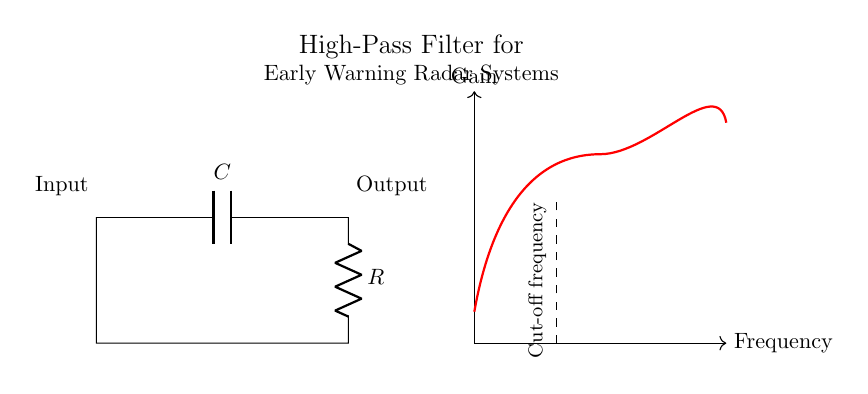What type of circuit is shown? The circuit is a high-pass filter, which is designed to allow high-frequency signals to pass through while attenuating low-frequency signals. This is indicated by the arrangement of components and the purpose stated in the title.
Answer: high-pass filter What are the components used in the circuit? The circuit contains a capacitor and a resistor, as indicated by the labels in the diagram. The capacitor is represented by C and the resistor by R.
Answer: capacitor and resistor What is the function of the capacitor in this circuit? The capacitor in a high-pass filter circuit blocks low-frequency signals while allowing high-frequency signals to pass. This is because capacitors have a frequency-dependent impedance, which decreases with increasing frequency.
Answer: block low frequencies What is the cut-off frequency? The cut-off frequency is the frequency at which the output voltage is reduced to about 70.7% of the input voltage, typically marked in frequency response graphs. In this diagram, it is indicated by a dashed line labeled "Cut-off frequency."
Answer: frequency at which output is reduced How does the arrangement of the components affect the frequency response? In this high-pass filter configuration, the capacitor is in series with the resistor. At low frequencies, the capacitor has a high reactance, preventing the signal from passing, while at high frequencies, its reactance decreases, allowing the signal to pass through effectively. This arrangement defines the filtering behavior of the circuit.
Answer: series arrangement allows high frequencies through What happens to the output if the input frequency is below the cut-off frequency? If the input frequency is below the cut-off frequency, the output voltage will be significantly lower than the input voltage due to the high impedance presented by the capacitor at those frequencies, meaning low-frequency signals are attenuated.
Answer: output is significantly lower What is the role of the resistor in this circuit? The resistor in this high-pass filter circuit works to define the time constant in combination with the capacitor, impacting the overall response and determining the cut-off frequency. It provides a discharge path for the capacitor, helping control the rate at which the circuit reacts to changes in the input signal.
Answer: define time constant 